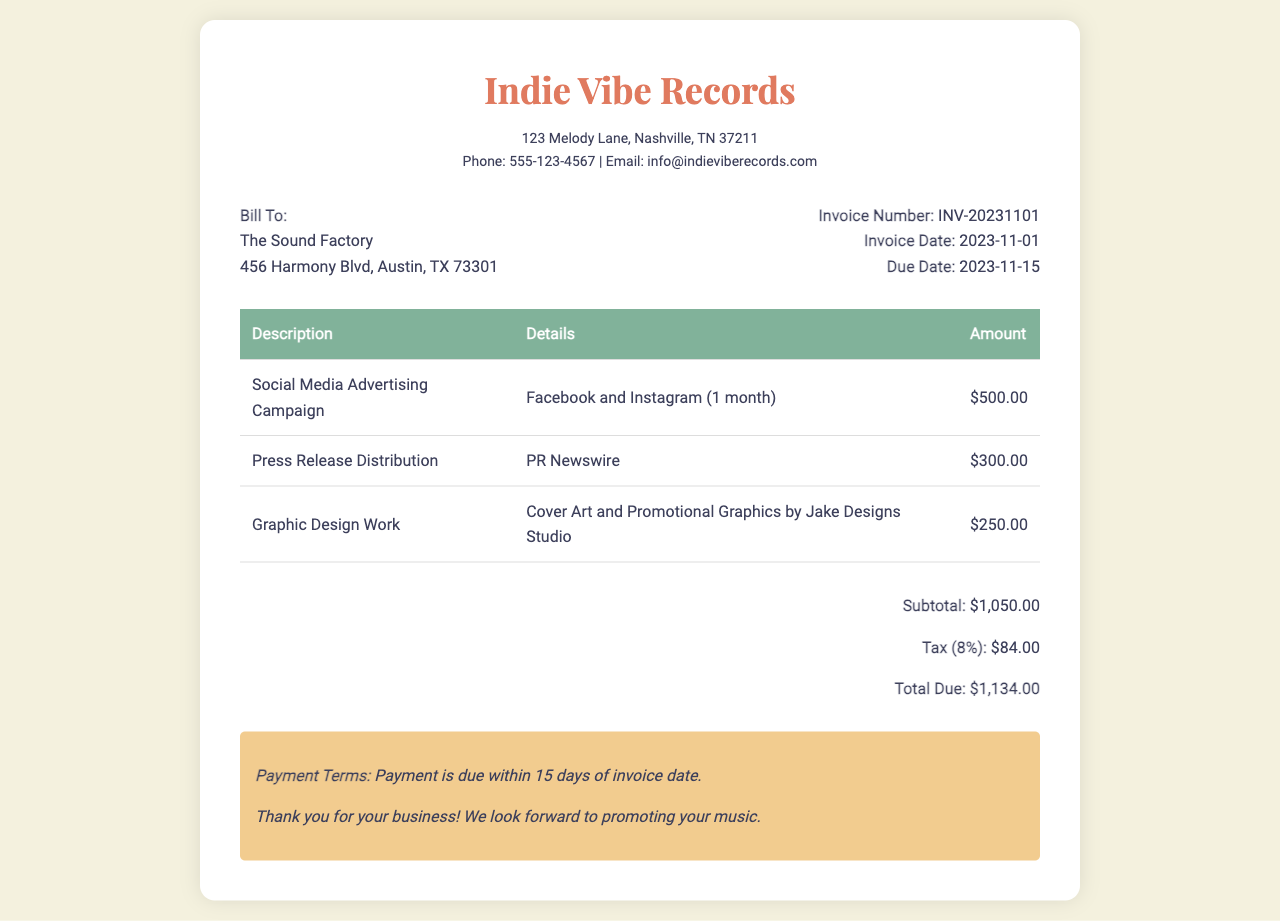what is the invoice number? The invoice number is listed directly in the invoice details section.
Answer: INV-20231101 what is the due date for payment? The due date is specified in the invoice details section as the deadline for payment.
Answer: 2023-11-15 who is the graphic design work for? The graphic design work details mention the name of the design studio providing the service.
Answer: Jake Designs Studio what is the amount for press release distribution? The amount for the specified service is clearly stated in the invoice table.
Answer: $300.00 what is the subtotal of the invoice? The subtotal reflects the sum of all listed service amounts before tax in the total section.
Answer: $1,050.00 how much tax is applied to the invoice? The tax amount is indicated as a percentage of the subtotal in the total section.
Answer: $84.00 what is the total due on the invoice? The total due is the final amount after tax and is listed at the bottom of the total section.
Answer: $1,134.00 what services are included in this invoice? The invoice lists specific services provided along with their respective details.
Answer: Social Media Advertising Campaign, Press Release Distribution, Graphic Design Work what payment terms are mentioned on the invoice? The invoice includes specific terms that outline the payment expectations.
Answer: Payment is due within 15 days of invoice date 